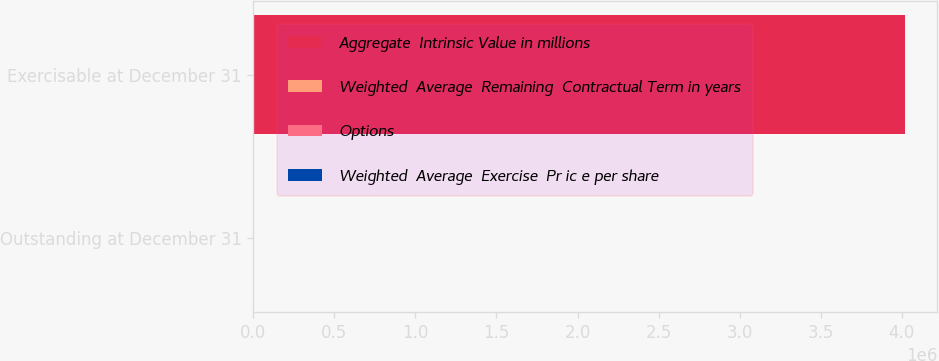<chart> <loc_0><loc_0><loc_500><loc_500><stacked_bar_chart><ecel><fcel>Outstanding at December 31<fcel>Exercisable at December 31<nl><fcel>Aggregate  Intrinsic Value in millions<fcel>52.87<fcel>4.01717e+06<nl><fcel>Weighted  Average  Remaining  Contractual Term in years<fcel>52.87<fcel>46.14<nl><fcel>Options<fcel>6.4<fcel>5.3<nl><fcel>Weighted  Average  Exercise  Pr ic e per share<fcel>209<fcel>161<nl></chart> 